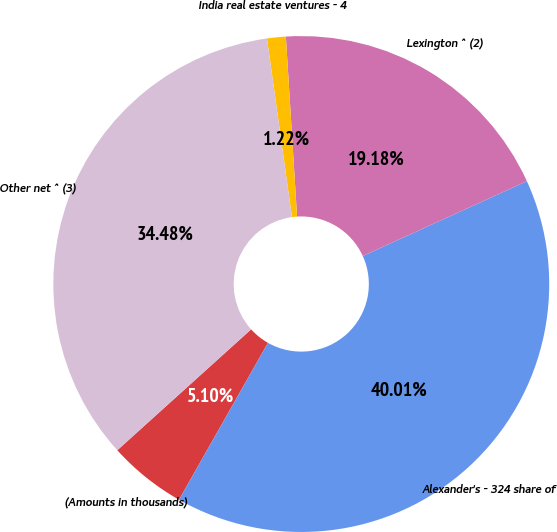Convert chart to OTSL. <chart><loc_0><loc_0><loc_500><loc_500><pie_chart><fcel>(Amounts in thousands)<fcel>Alexander's - 324 share of<fcel>Lexington ^ (2)<fcel>India real estate ventures - 4<fcel>Other net ^ (3)<nl><fcel>5.1%<fcel>40.01%<fcel>19.18%<fcel>1.22%<fcel>34.48%<nl></chart> 